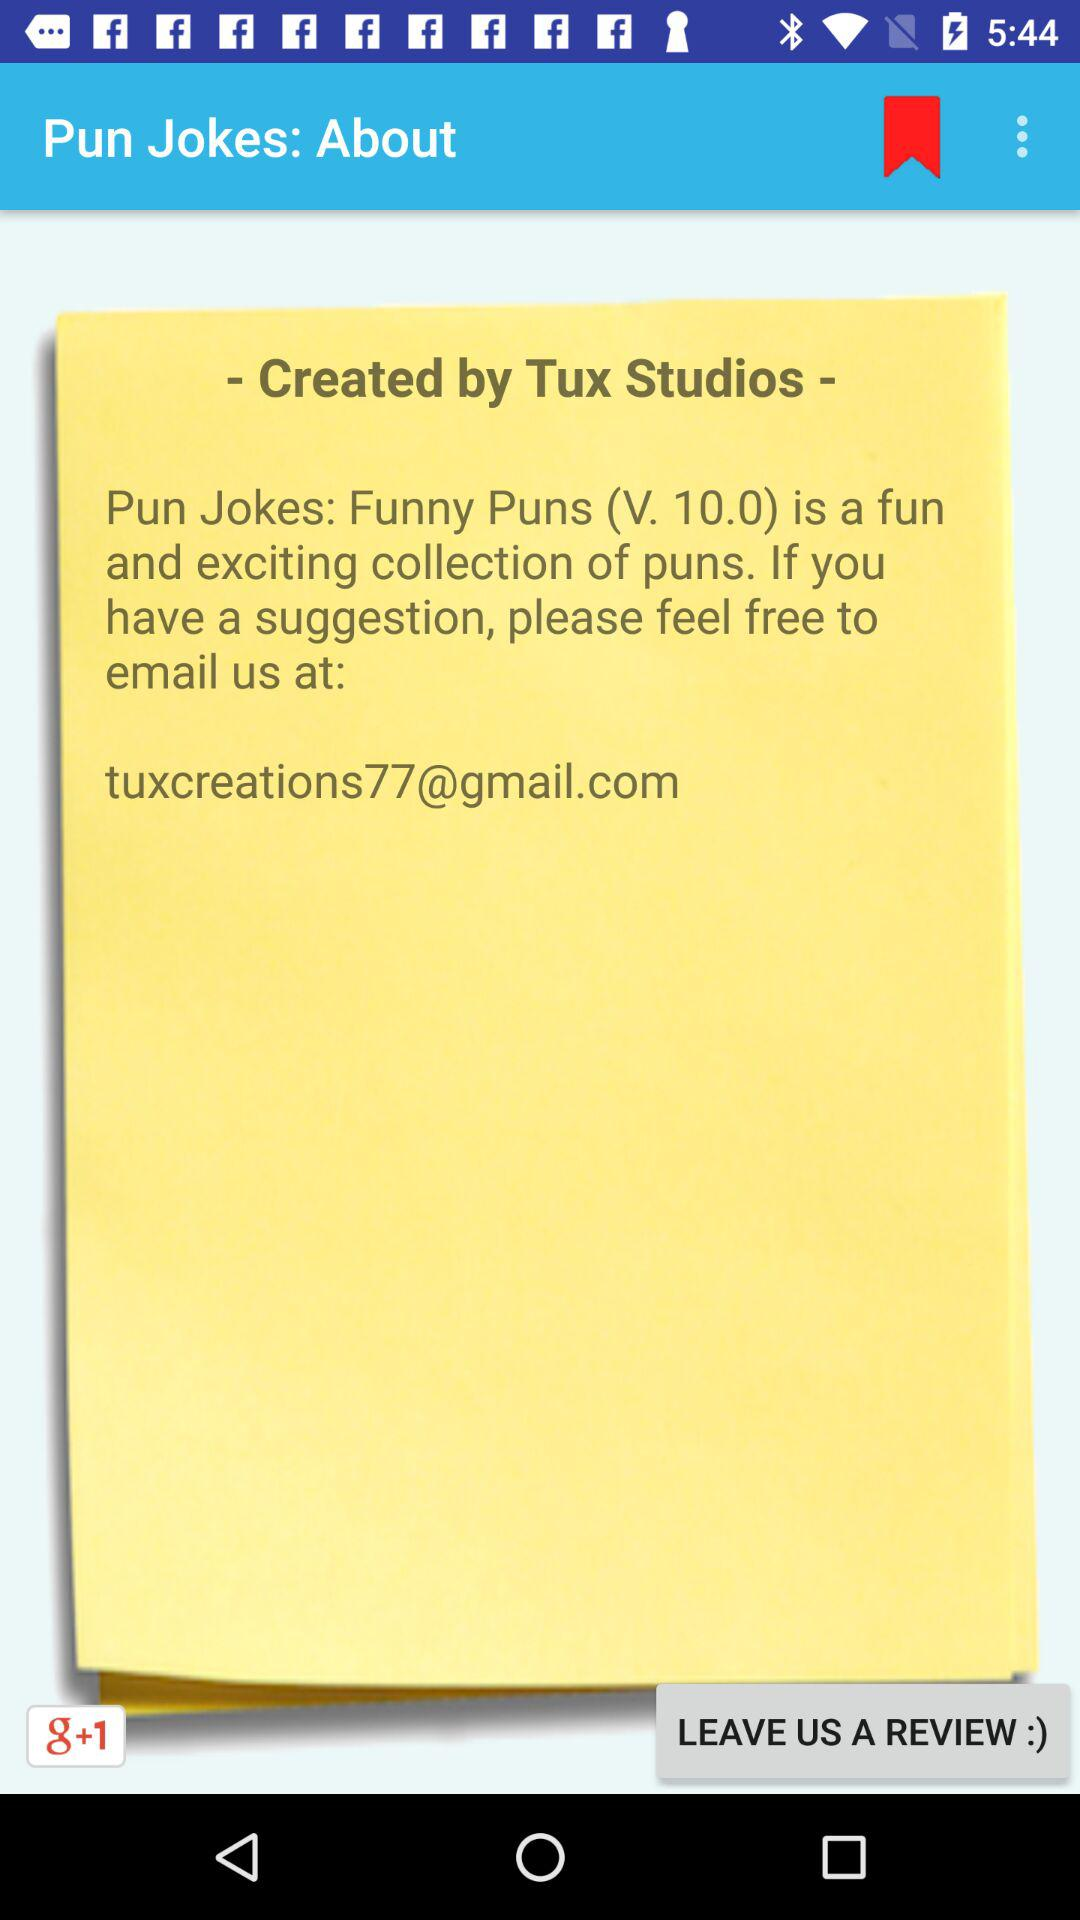How many more dots are there than bookmarks?
Answer the question using a single word or phrase. 2 